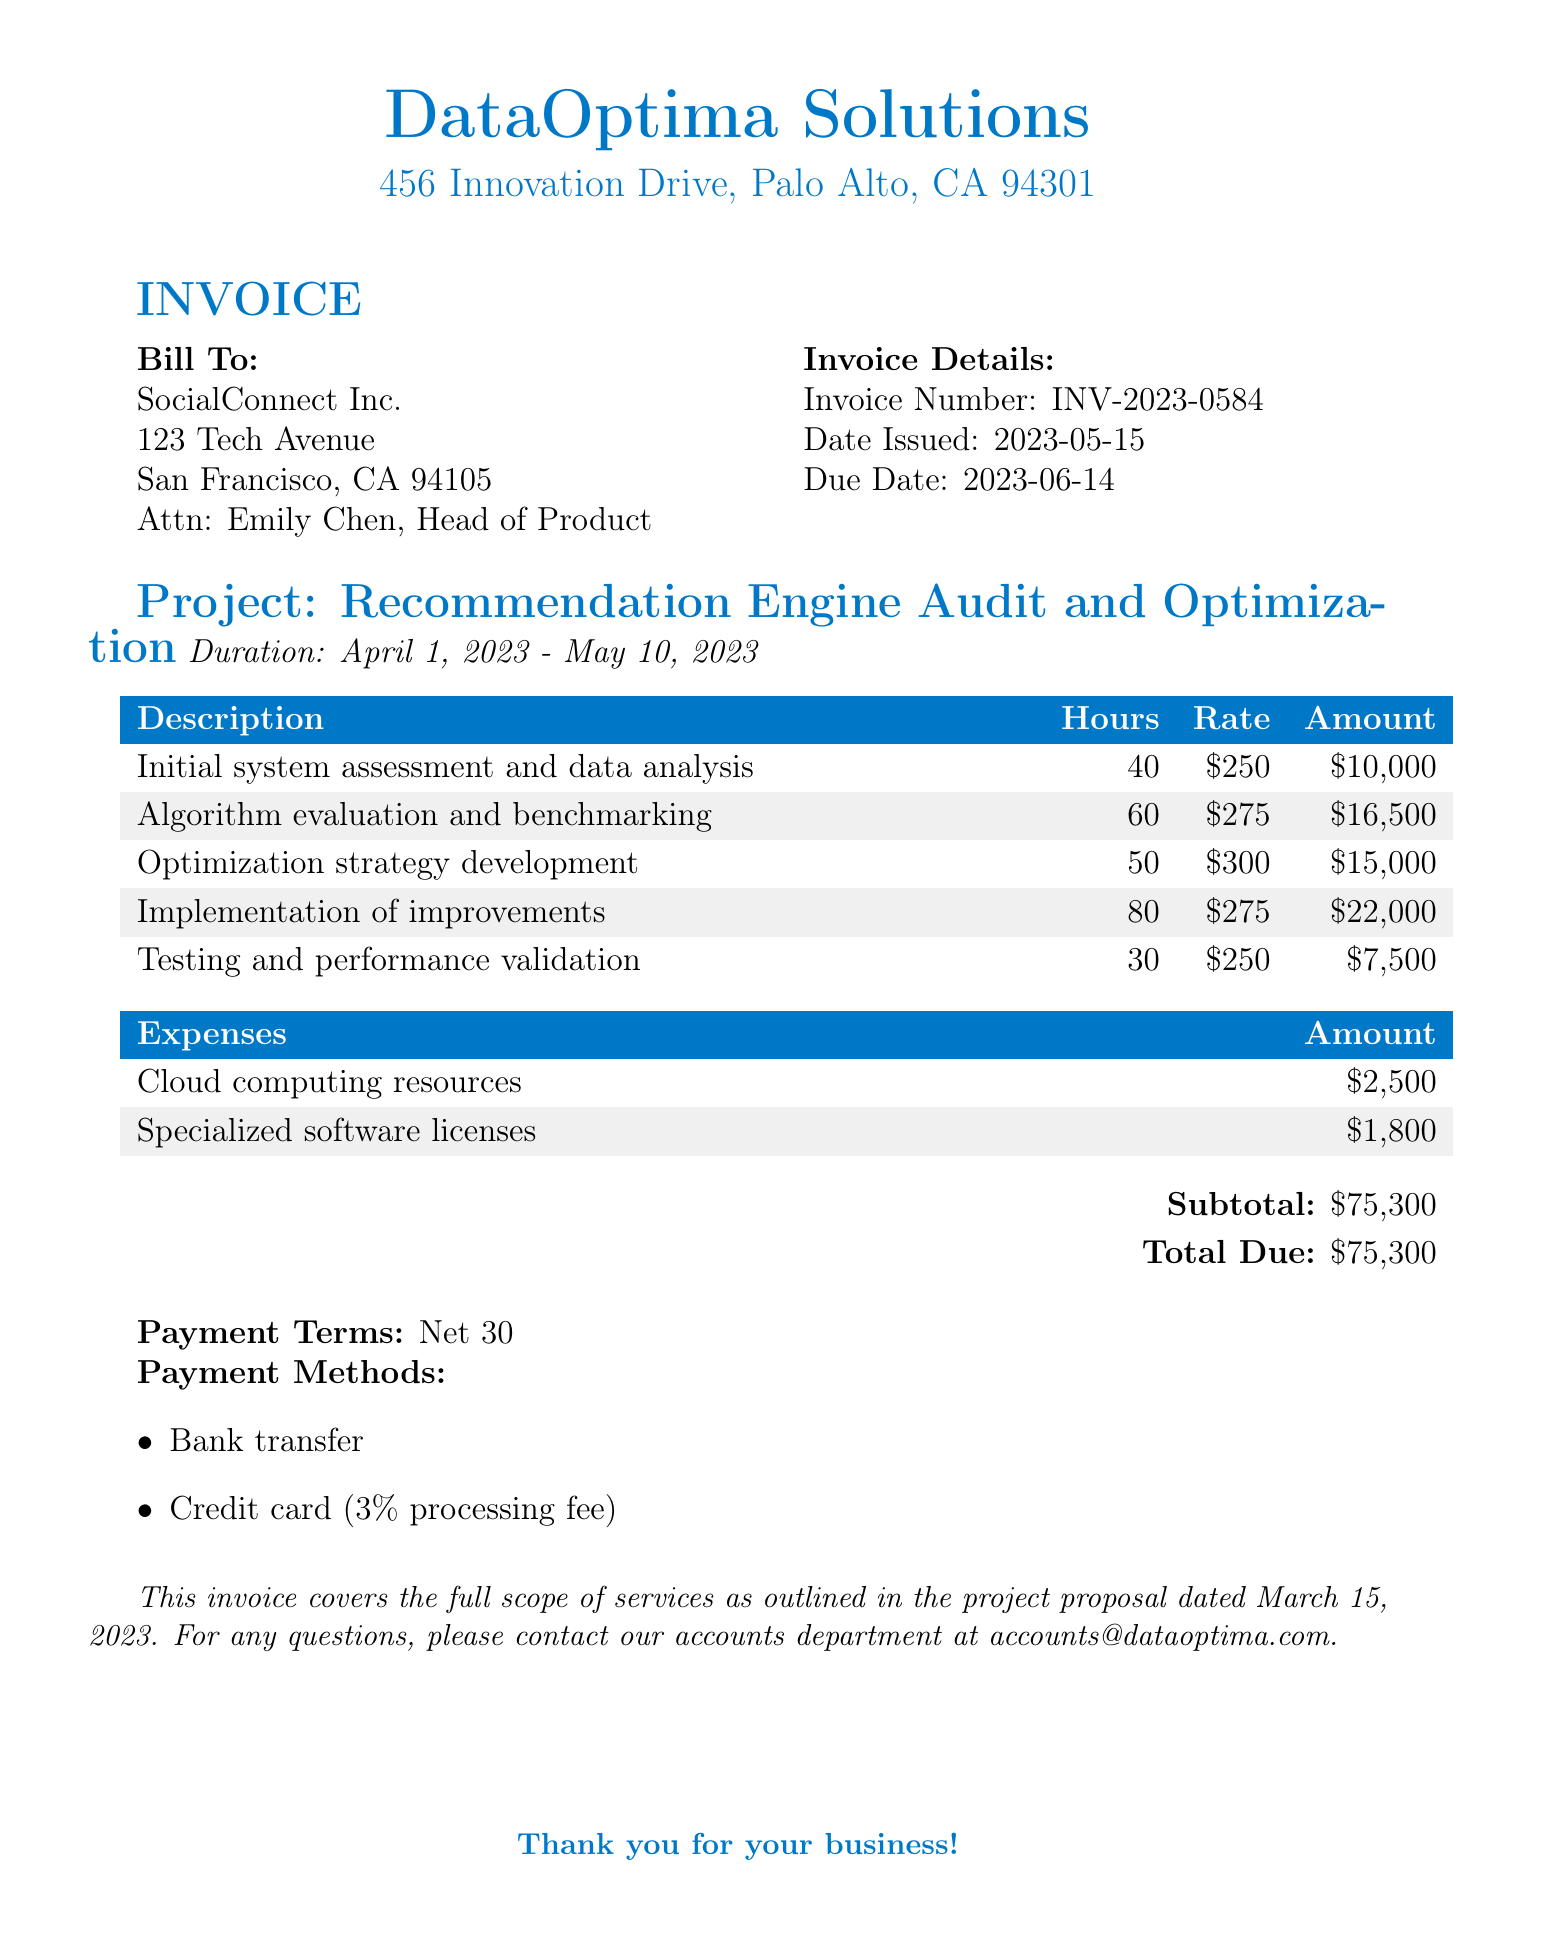What is the name of the consulting company? The consulting company is identified at the top of the document as "DataOptima Solutions."
Answer: DataOptima Solutions What is the invoice number? The invoice number is specified in the invoice details section as "INV-2023-0584."
Answer: INV-2023-0584 Who is the billable contact at SocialConnect Inc.? The contact person for billing is mentioned at the beginning as "Emily Chen, Head of Product."
Answer: Emily Chen, Head of Product What is the total amount due on the invoice? The total amount due is calculated and presented at the bottom of the invoice as "$75,300."
Answer: $75,300 What was the duration of the project? The project duration is listed in the document as "April 1, 2023 - May 10, 2023."
Answer: April 1, 2023 - May 10, 2023 How many hours were spent on the implementation of improvements? The document specifies that 80 hours were allocated to the implementation of improvements.
Answer: 80 What is the payment term mentioned in the invoice? The payment terms in the document are stated as "Net 30."
Answer: Net 30 What expenses were incurred for specialized software licenses? The document indicates that expenses for specialized software licenses amounted to "$1,800."
Answer: $1,800 What payment methods are accepted for this invoice? The document outlines two payment methods: bank transfer and credit card, with a processing fee.
Answer: Bank transfer, credit card 